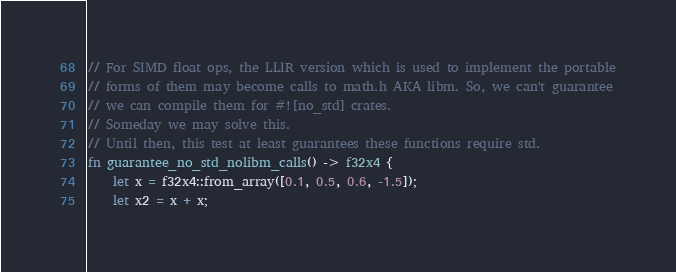Convert code to text. <code><loc_0><loc_0><loc_500><loc_500><_Rust_>
// For SIMD float ops, the LLIR version which is used to implement the portable
// forms of them may become calls to math.h AKA libm. So, we can't guarantee
// we can compile them for #![no_std] crates.
// Someday we may solve this.
// Until then, this test at least guarantees these functions require std.
fn guarantee_no_std_nolibm_calls() -> f32x4 {
    let x = f32x4::from_array([0.1, 0.5, 0.6, -1.5]);
    let x2 = x + x;</code> 